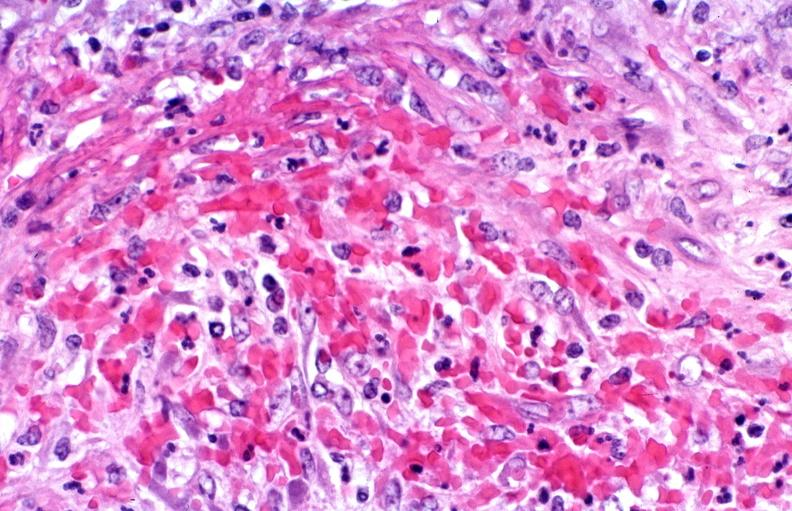what is present?
Answer the question using a single word or phrase. Vasculature 